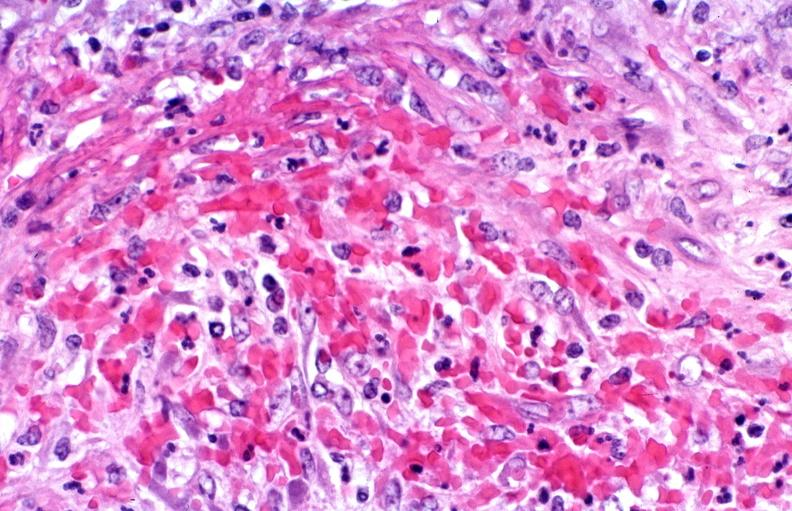what is present?
Answer the question using a single word or phrase. Vasculature 